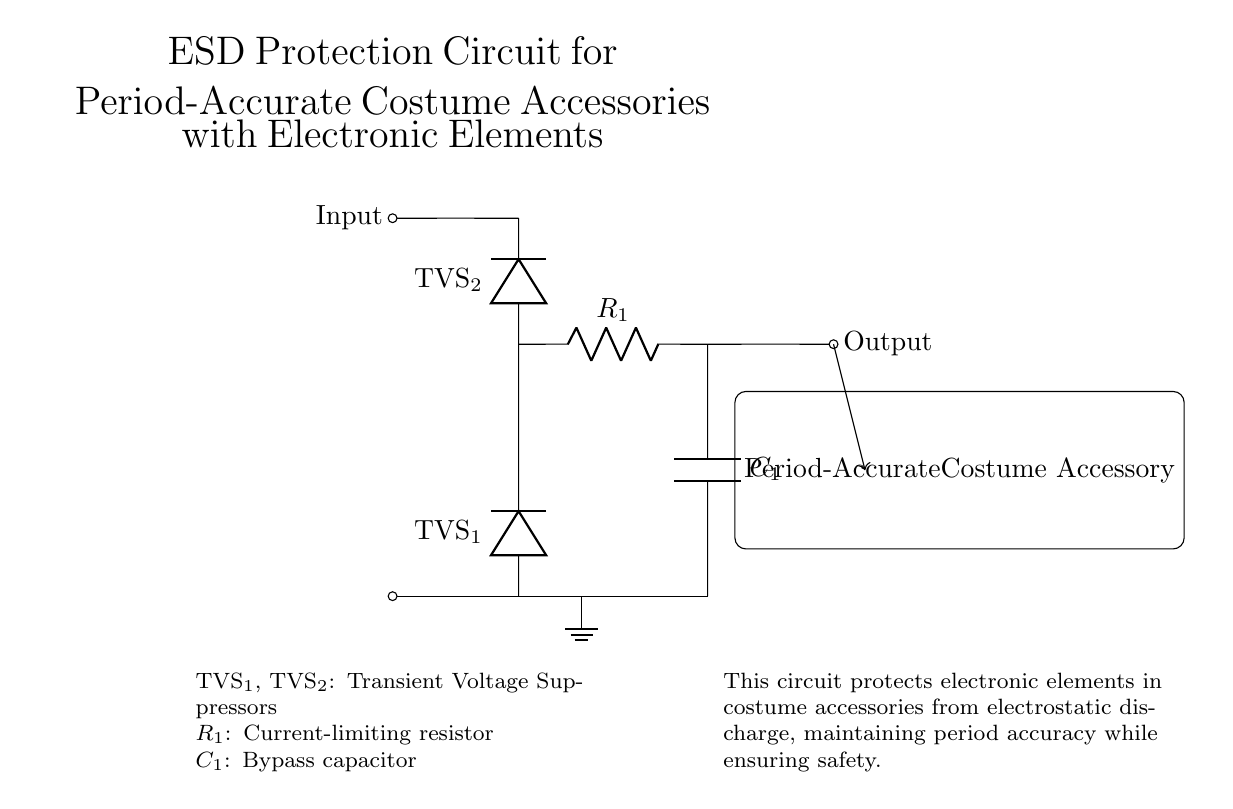What type of components are used for ESD protection? The components used for ESD protection are transient voltage suppressors. Two TVS diodes are indicated in the diagram as TVS1 and TVS2, connected across the input line.
Answer: transient voltage suppressors How many resistors are present in this circuit? There is one resistor shown in the diagram labeled R1. It is located in series with the output after the transient voltage suppressors.
Answer: one Which component is responsible for bypassing high-frequency noise? The component responsible for bypassing high-frequency noise is the capacitor labeled C1. It connects the output line to ground, allowing high-frequency signals to be shunted away.
Answer: capacitor What is the purpose of resistor R1 in this circuit? The purpose of resistor R1 is to limit the current. It is placed in series with the output to avoid excessive current flow through the electronic elements connected downstream.
Answer: limit current How do the TVS diodes function within the protection circuit? The TVS diodes function by clamping voltage spikes that exceed their breakdown voltage. When a voltage spike occurs due to ESD, the TVS diodes shunt the excess energy to ground, protecting the components.
Answer: clamp voltage spikes What is the role of C1 in the circuit? The role of C1 is to act as a bypass capacitor. It stabilizes the voltage and filters out noise, connecting the output to ground. This helps maintain a smoother voltage level in the circuit.
Answer: bypass capacitor What type of accessory is protected by this circuit? The accessory protected by this circuit is a period-accurate costume accessory. The circuit is designed to shield the electronic elements in such accessories from ESD, while maintaining their historical authenticity.
Answer: period-accurate costume accessory 